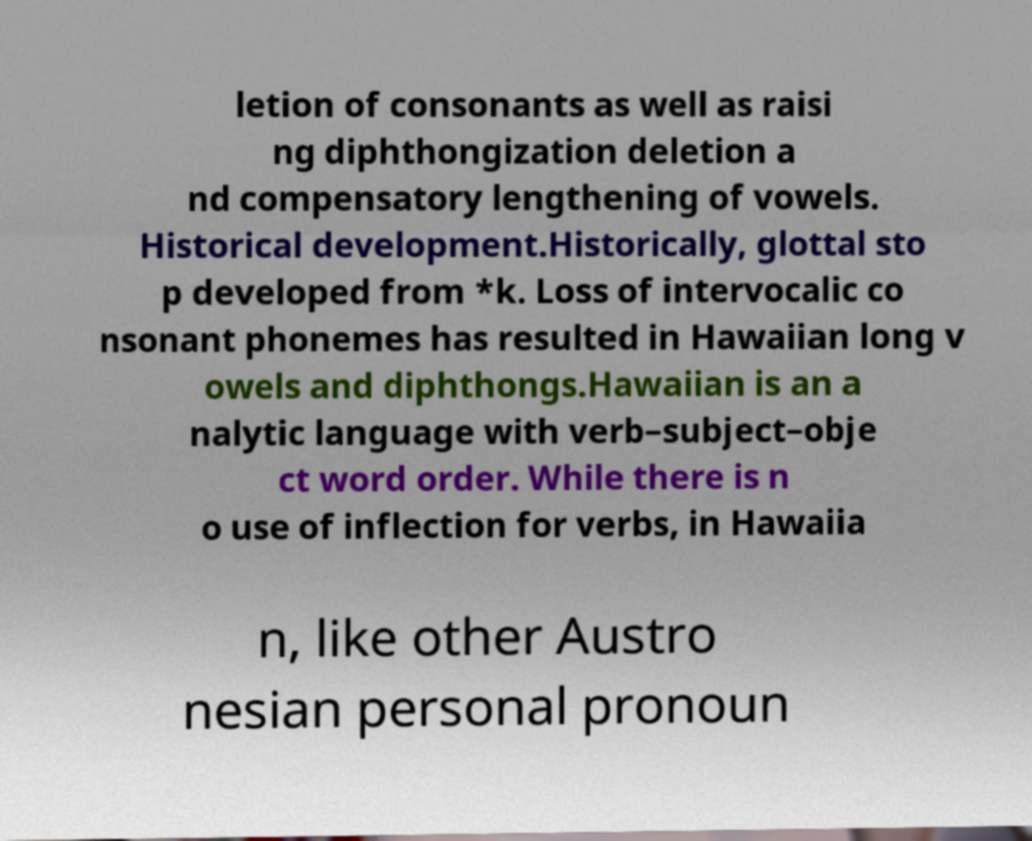Could you assist in decoding the text presented in this image and type it out clearly? letion of consonants as well as raisi ng diphthongization deletion a nd compensatory lengthening of vowels. Historical development.Historically, glottal sto p developed from *k. Loss of intervocalic co nsonant phonemes has resulted in Hawaiian long v owels and diphthongs.Hawaiian is an a nalytic language with verb–subject–obje ct word order. While there is n o use of inflection for verbs, in Hawaiia n, like other Austro nesian personal pronoun 